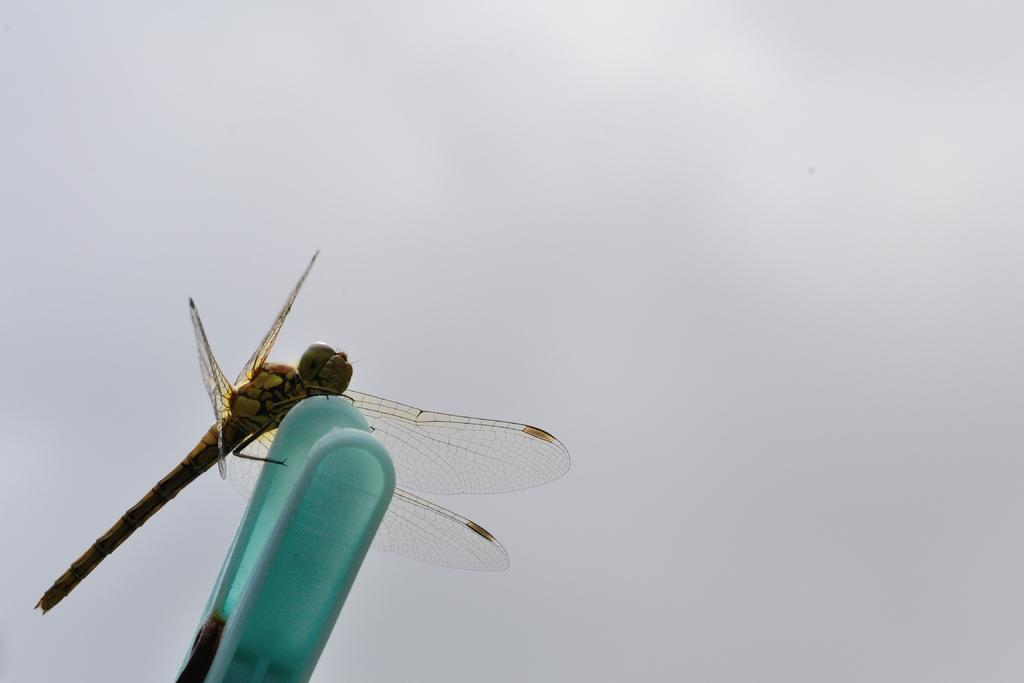What insect can be seen in the image? There is a dragonfly in the image. How is the dragonfly positioned in the image? The dragonfly is on a clip. What can be seen in the background of the image? There is a cloudy sky in the background of the image. What type of ship can be seen sailing on the side of the dragonfly in the image? There is no ship present in the image; it features a dragonfly on a clip with a cloudy sky in the background. 